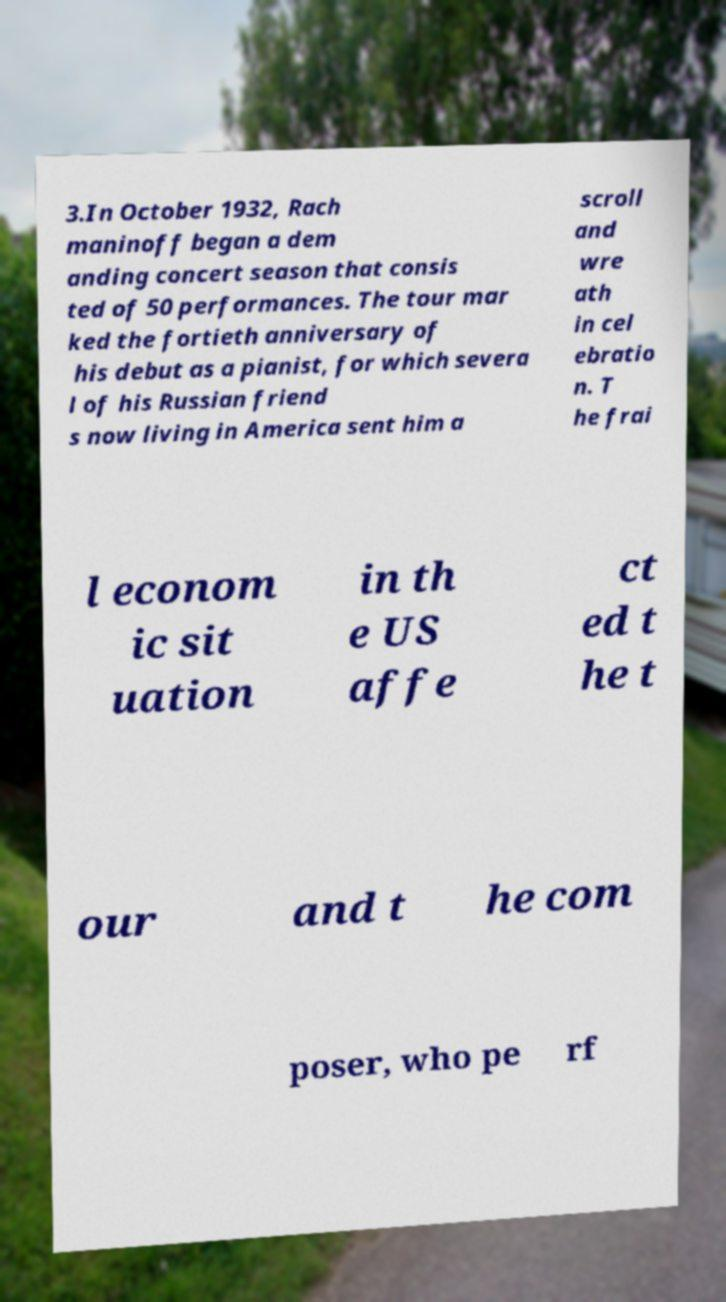Please read and relay the text visible in this image. What does it say? 3.In October 1932, Rach maninoff began a dem anding concert season that consis ted of 50 performances. The tour mar ked the fortieth anniversary of his debut as a pianist, for which severa l of his Russian friend s now living in America sent him a scroll and wre ath in cel ebratio n. T he frai l econom ic sit uation in th e US affe ct ed t he t our and t he com poser, who pe rf 